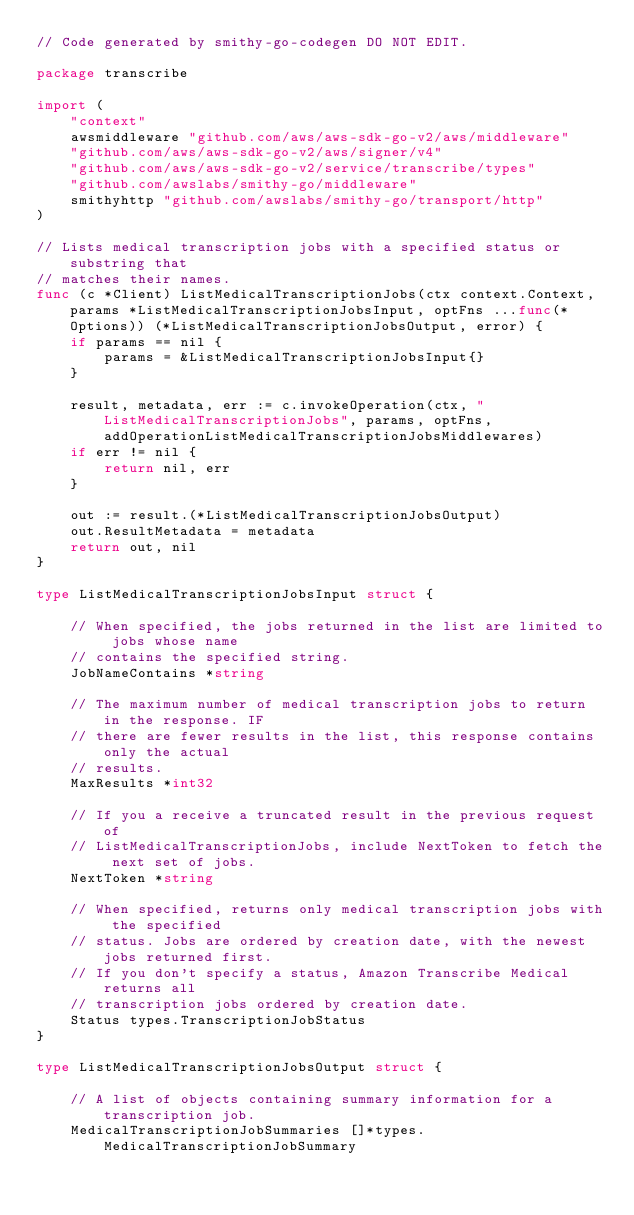Convert code to text. <code><loc_0><loc_0><loc_500><loc_500><_Go_>// Code generated by smithy-go-codegen DO NOT EDIT.

package transcribe

import (
	"context"
	awsmiddleware "github.com/aws/aws-sdk-go-v2/aws/middleware"
	"github.com/aws/aws-sdk-go-v2/aws/signer/v4"
	"github.com/aws/aws-sdk-go-v2/service/transcribe/types"
	"github.com/awslabs/smithy-go/middleware"
	smithyhttp "github.com/awslabs/smithy-go/transport/http"
)

// Lists medical transcription jobs with a specified status or substring that
// matches their names.
func (c *Client) ListMedicalTranscriptionJobs(ctx context.Context, params *ListMedicalTranscriptionJobsInput, optFns ...func(*Options)) (*ListMedicalTranscriptionJobsOutput, error) {
	if params == nil {
		params = &ListMedicalTranscriptionJobsInput{}
	}

	result, metadata, err := c.invokeOperation(ctx, "ListMedicalTranscriptionJobs", params, optFns, addOperationListMedicalTranscriptionJobsMiddlewares)
	if err != nil {
		return nil, err
	}

	out := result.(*ListMedicalTranscriptionJobsOutput)
	out.ResultMetadata = metadata
	return out, nil
}

type ListMedicalTranscriptionJobsInput struct {

	// When specified, the jobs returned in the list are limited to jobs whose name
	// contains the specified string.
	JobNameContains *string

	// The maximum number of medical transcription jobs to return in the response. IF
	// there are fewer results in the list, this response contains only the actual
	// results.
	MaxResults *int32

	// If you a receive a truncated result in the previous request of
	// ListMedicalTranscriptionJobs, include NextToken to fetch the next set of jobs.
	NextToken *string

	// When specified, returns only medical transcription jobs with the specified
	// status. Jobs are ordered by creation date, with the newest jobs returned first.
	// If you don't specify a status, Amazon Transcribe Medical returns all
	// transcription jobs ordered by creation date.
	Status types.TranscriptionJobStatus
}

type ListMedicalTranscriptionJobsOutput struct {

	// A list of objects containing summary information for a transcription job.
	MedicalTranscriptionJobSummaries []*types.MedicalTranscriptionJobSummary
</code> 